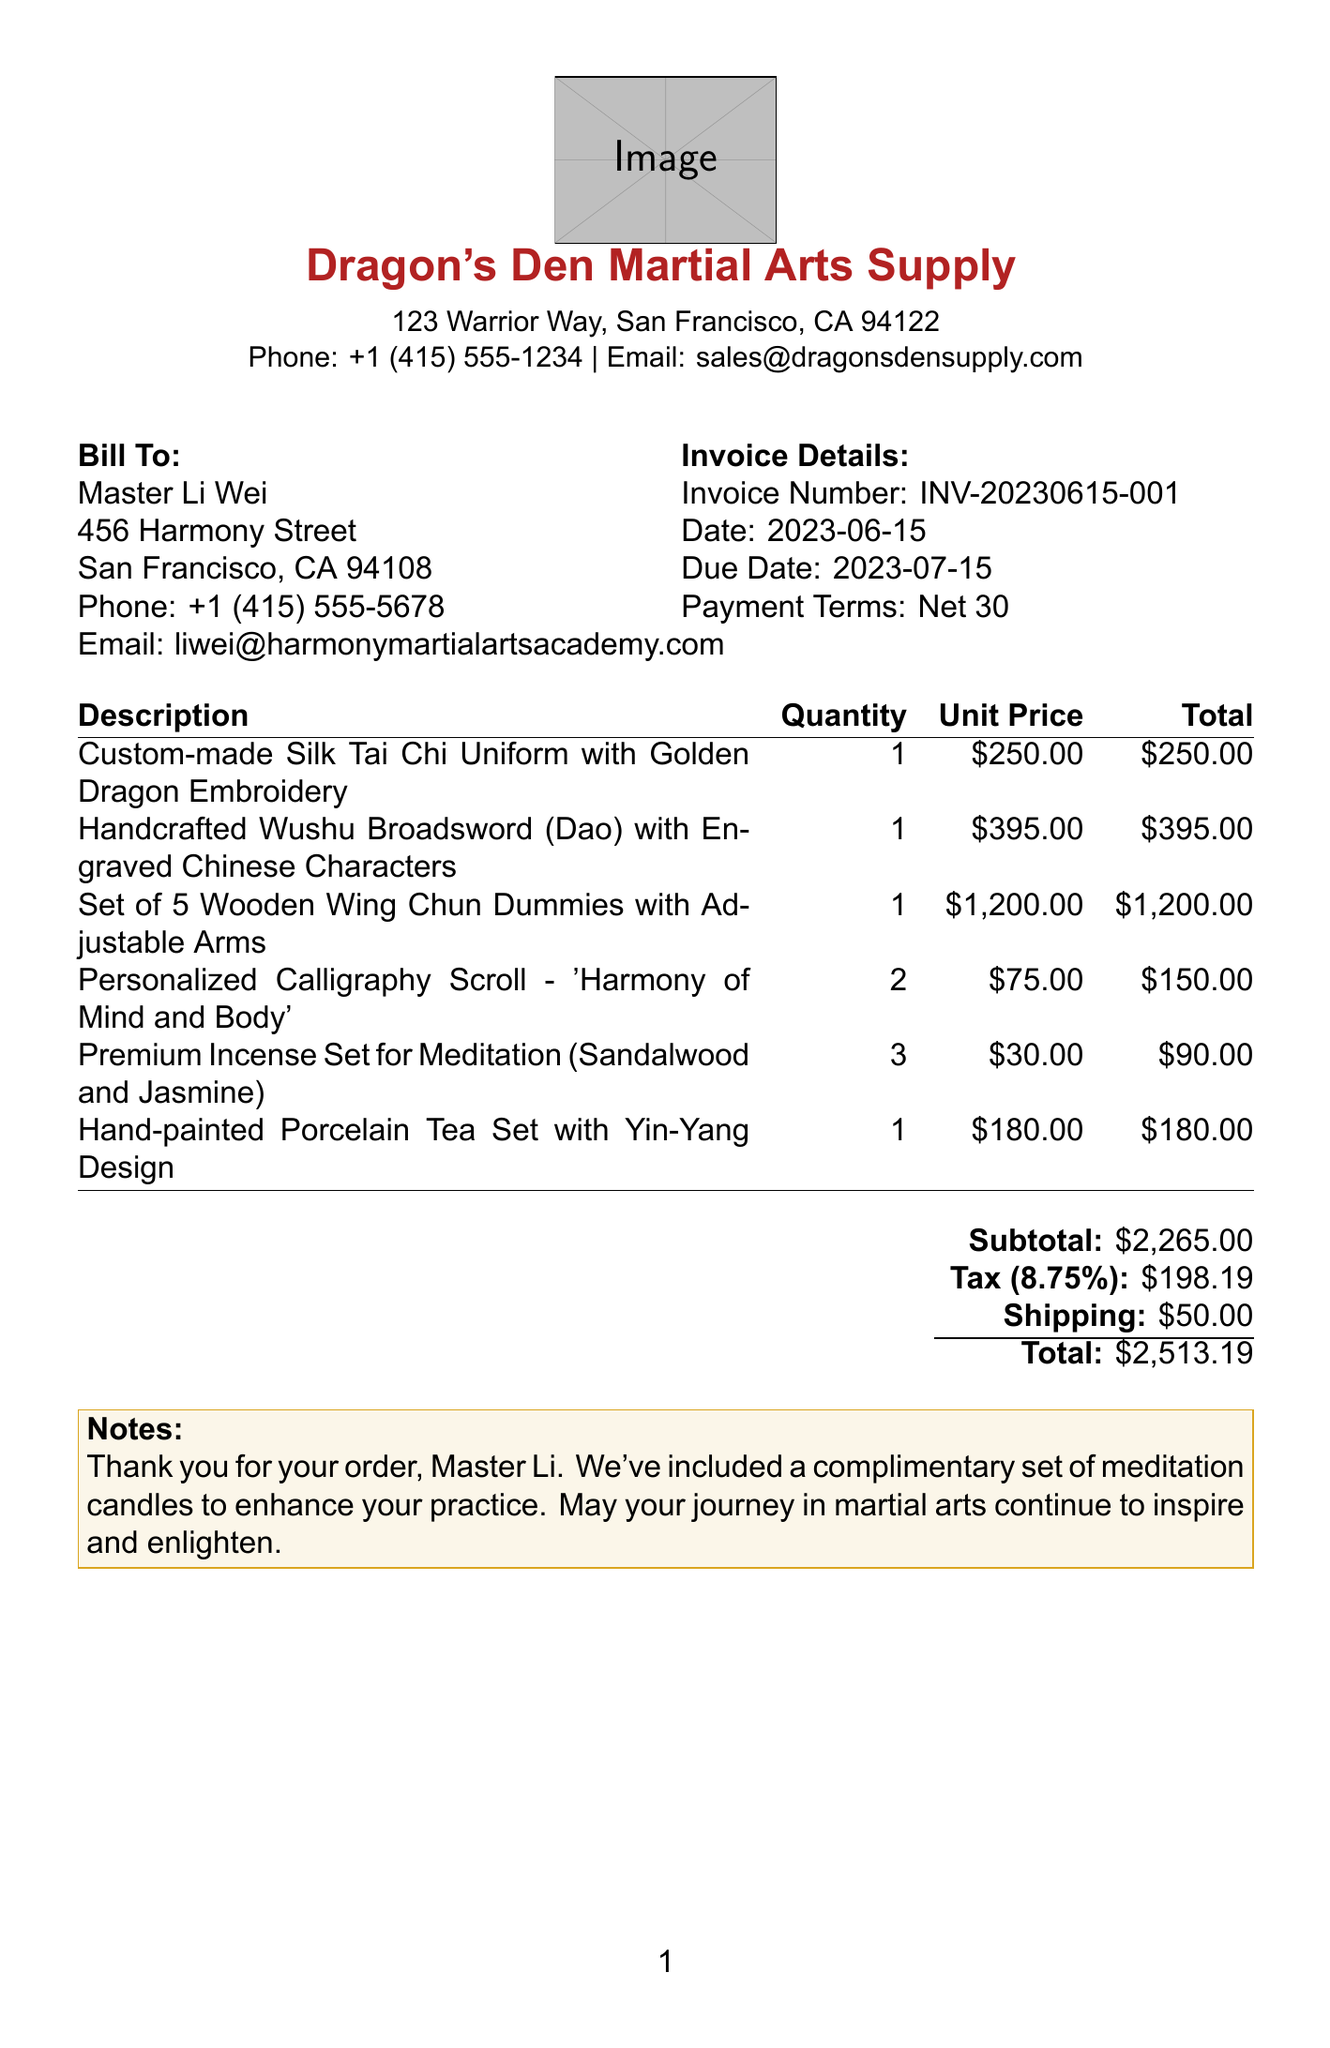What is the invoice number? The invoice number is explicitly stated in the document as "INV-20230615-001."
Answer: INV-20230615-001 Who is the seller? The seller is located in the seller section of the document, named "Dragon's Den Martial Arts Supply."
Answer: Dragon's Den Martial Arts Supply What is the total amount due? The total amount is presented at the bottom of the invoice, which is "$2,513.19."
Answer: $2,513.19 How many Personalized Calligraphy Scrolls were purchased? The quantity purchased can be found under the itemized list where it shows "2" for the Personalized Calligraphy Scroll.
Answer: 2 What is the shipping cost? The shipping cost is listed in the calculations section of the invoice, shown as "$50.00."
Answer: $50.00 What is the due date for the invoice? The due date is specified in the invoice details section as "2023-07-15."
Answer: 2023-07-15 How many different items are listed in the invoice? The document lists a total of six different items in the itemized section.
Answer: 6 What is the tax rate applied? The tax rate is detailed in the calculations section and is stated as "8.75%."
Answer: 8.75% What is included as a complimentary gift? A note included in the document mentions a complimentary set of meditation candles.
Answer: Meditation candles 